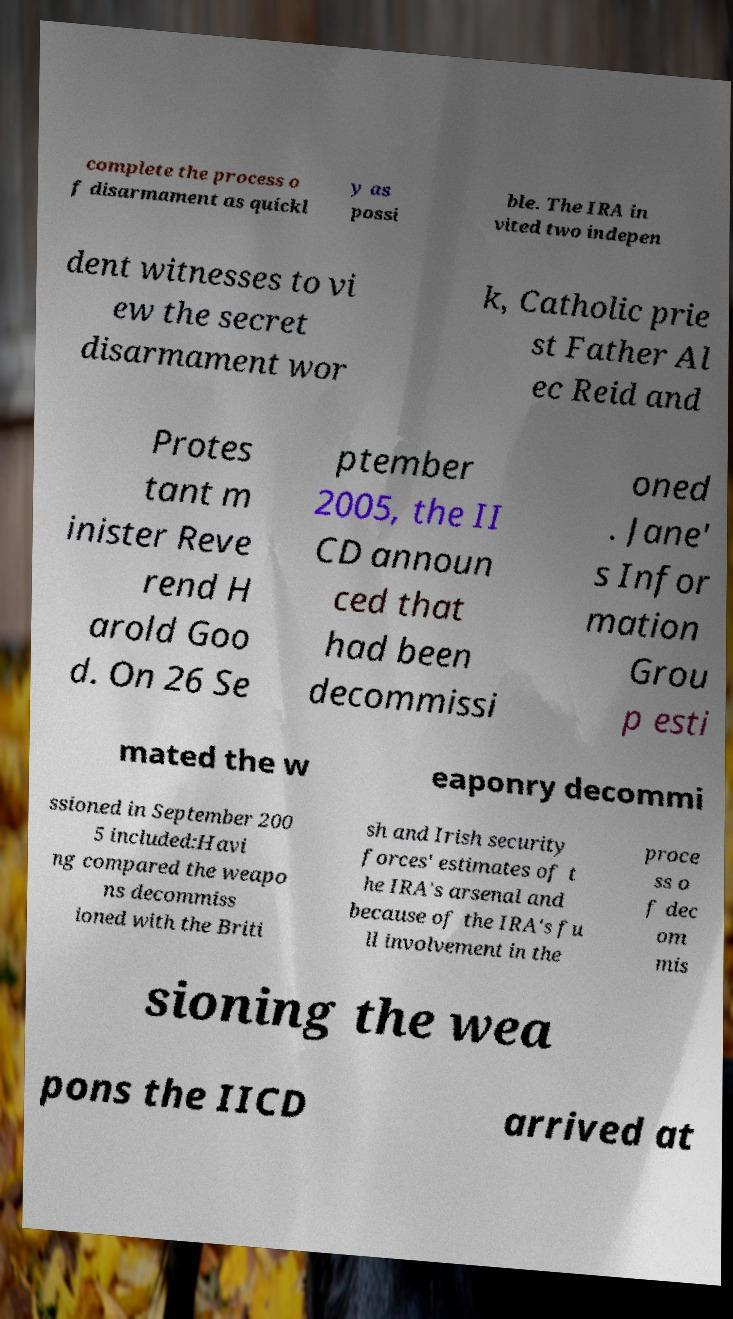Could you assist in decoding the text presented in this image and type it out clearly? complete the process o f disarmament as quickl y as possi ble. The IRA in vited two indepen dent witnesses to vi ew the secret disarmament wor k, Catholic prie st Father Al ec Reid and Protes tant m inister Reve rend H arold Goo d. On 26 Se ptember 2005, the II CD announ ced that had been decommissi oned . Jane' s Infor mation Grou p esti mated the w eaponry decommi ssioned in September 200 5 included:Havi ng compared the weapo ns decommiss ioned with the Briti sh and Irish security forces' estimates of t he IRA's arsenal and because of the IRA's fu ll involvement in the proce ss o f dec om mis sioning the wea pons the IICD arrived at 